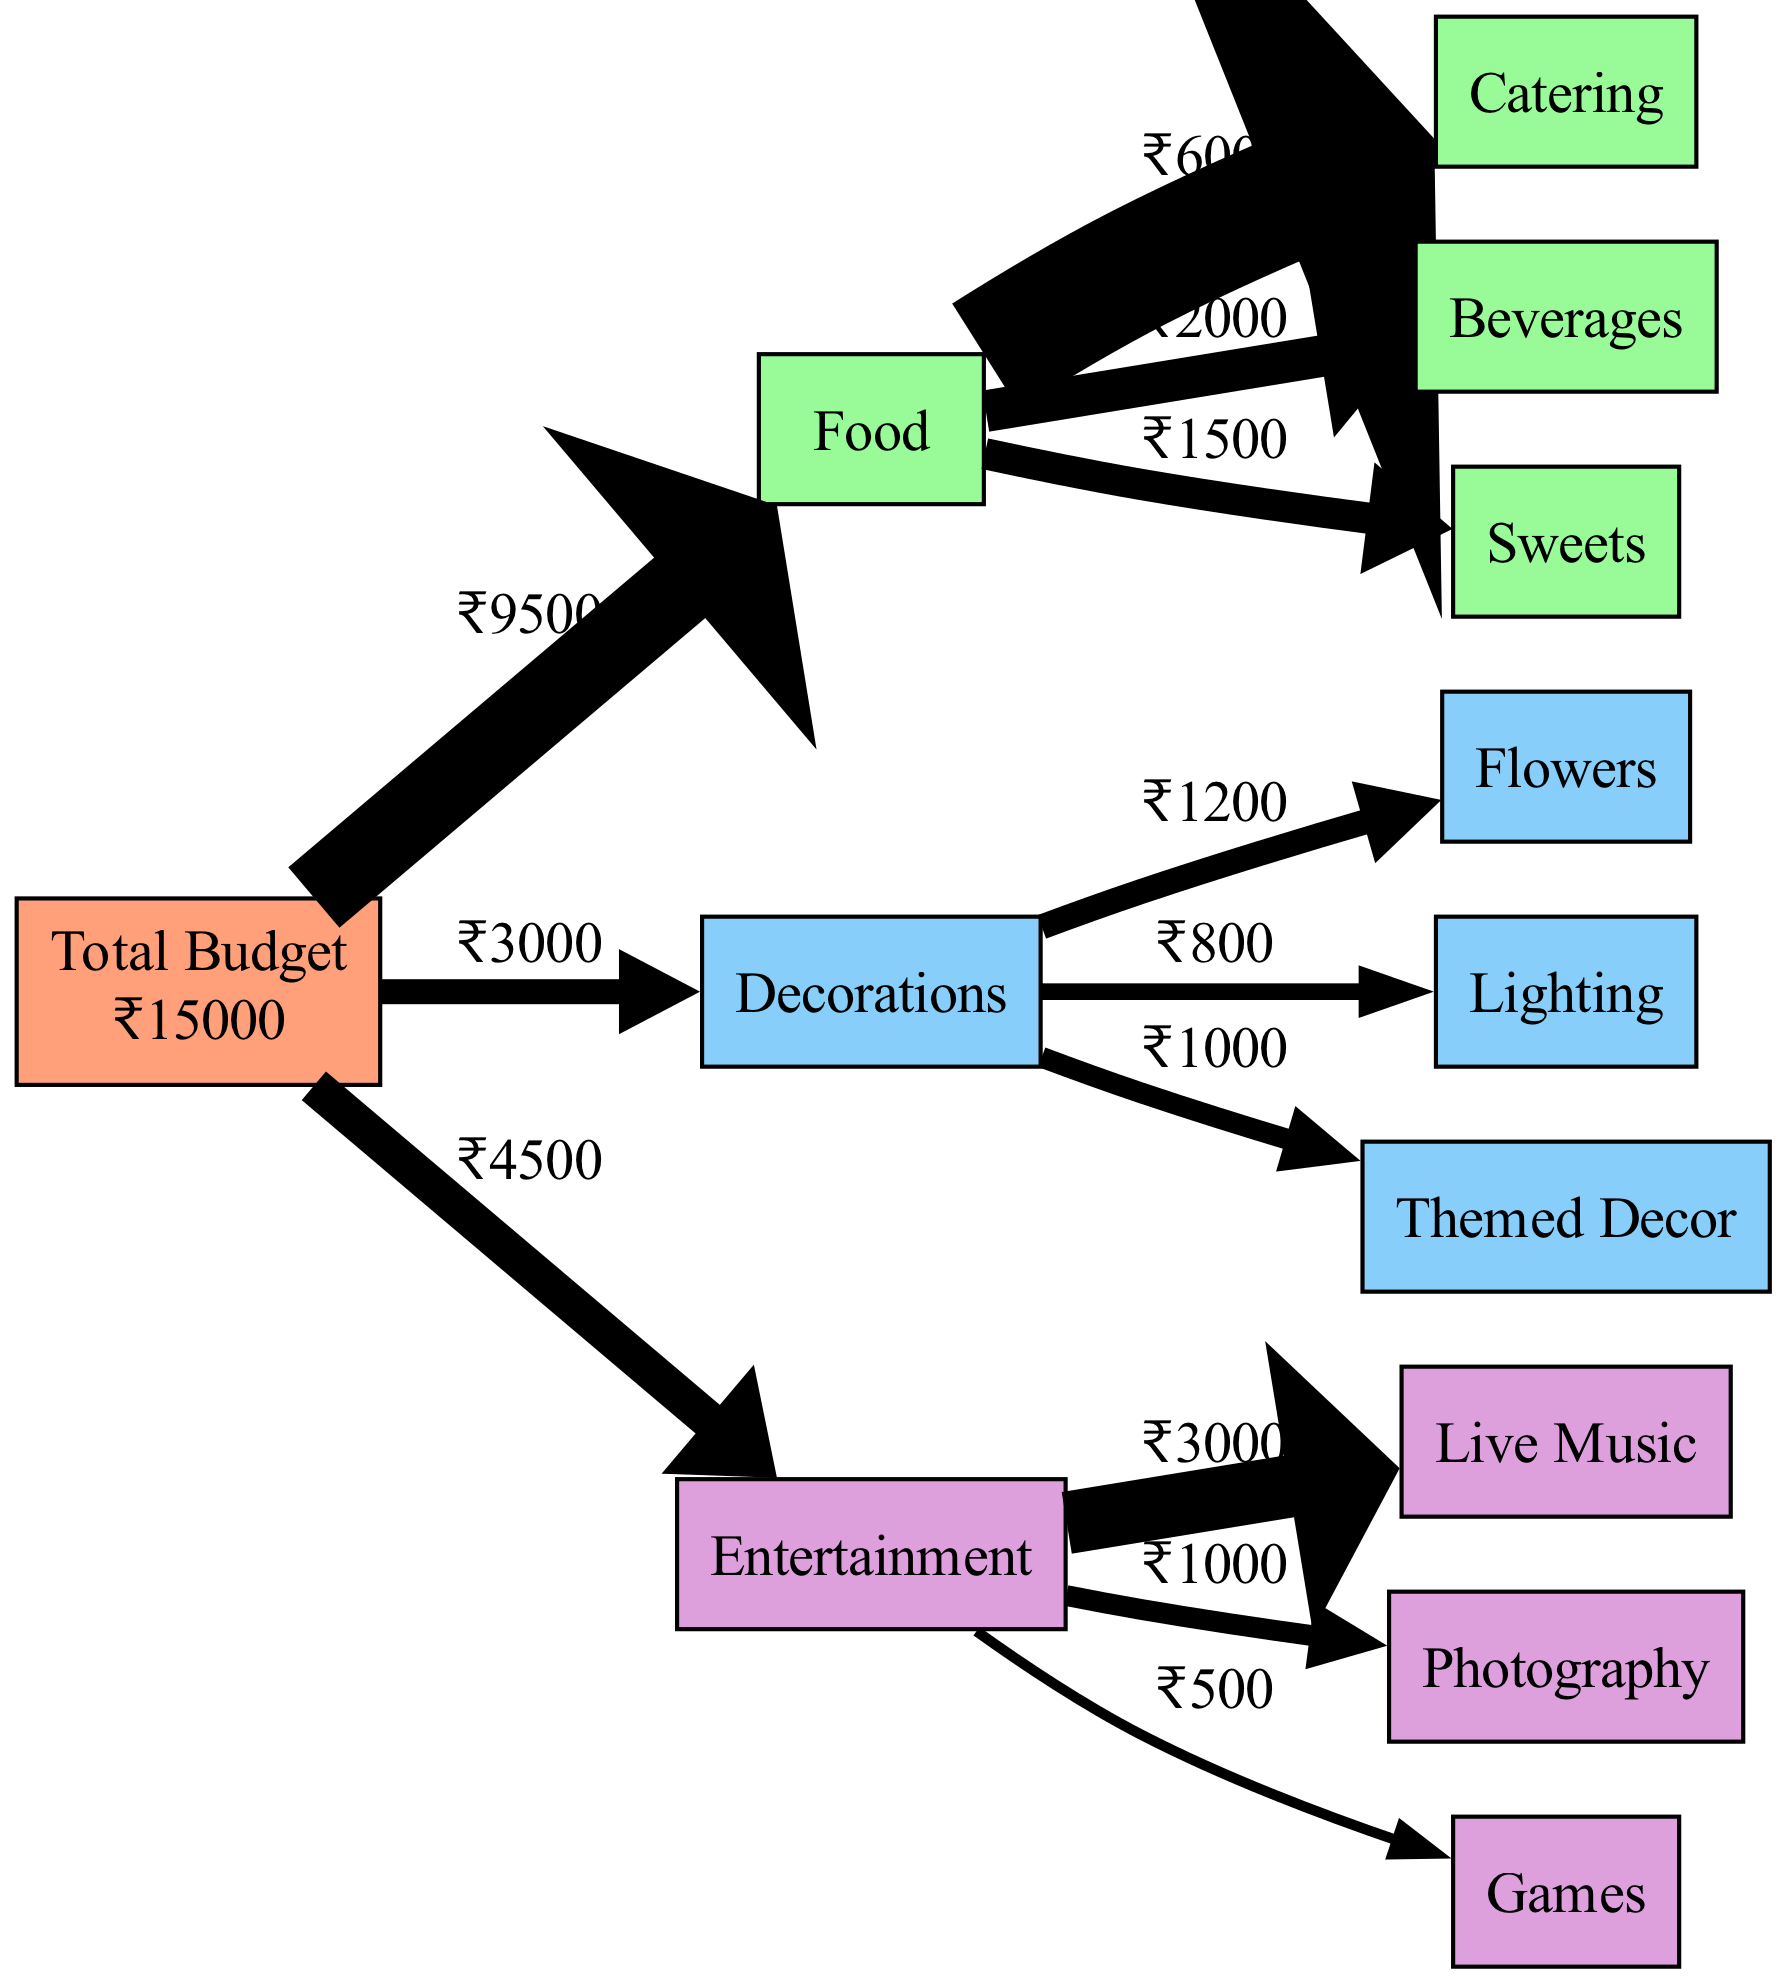What is the total budget for the family celebration? The total budget node directly states that the total is ₹15000. This is the first piece of information provided and is clearly indicated.
Answer: ₹15000 How much is allocated for food? The food node connects directly from the total budget and has a label indicating a total of ₹10000, which combines catering, beverages, and sweets. This can be calculated by summing those expenses: 6000 + 2000 + 1500 = 10000.
Answer: ₹10000 Which category has the highest individual expense? Looking at each category's individual expenses, live music within the entertainment category shows the highest amount at ₹3000. This can be reasoned through visual comparison of all the subcategory amounts.
Answer: Live Music What is the total spending on decorations? The decorations category total is listed as ₹3000. This is derived from the individual decoration expenses of flowers, lighting, and themed decor, which sum to 1200 + 800 + 1000 = 3000.
Answer: ₹3000 How much is spent on beverages? The beverages subcategory under food clearly states an amount of ₹2000. This information is straightforward and is displayed directly on the diagram.
Answer: ₹2000 Which category comprises the most number of subcategories? The food category has three subcategories: catering, beverages, and sweets, which is more than the decorations and entertainment categories that each have three and three respectively, but they only have single connections, making food the most comprehensive in terms of expense types.
Answer: Food What percentage of the total budget is spent on entertainment? The total expense for entertainment is ₹4500 (3000 + 1000 + 500). To find the percentage of the total budget this represents, we calculate (4500/15000)*100, which equals 30%.
Answer: 30% How many total expenses are listed in the diagram? There are a total of 9 expenses listed across all categories: 3 for food, 3 for decorations, and 3 for entertainment. By adding these together, we find the total is 3 + 3 + 3 = 9.
Answer: 9 What is the difference between the total food spending and the total decoration spending? The food spending totals ₹10000, while decorations total ₹3000. To find the difference, we subtract the two: 10000 - 3000 = 7000.
Answer: ₹7000 